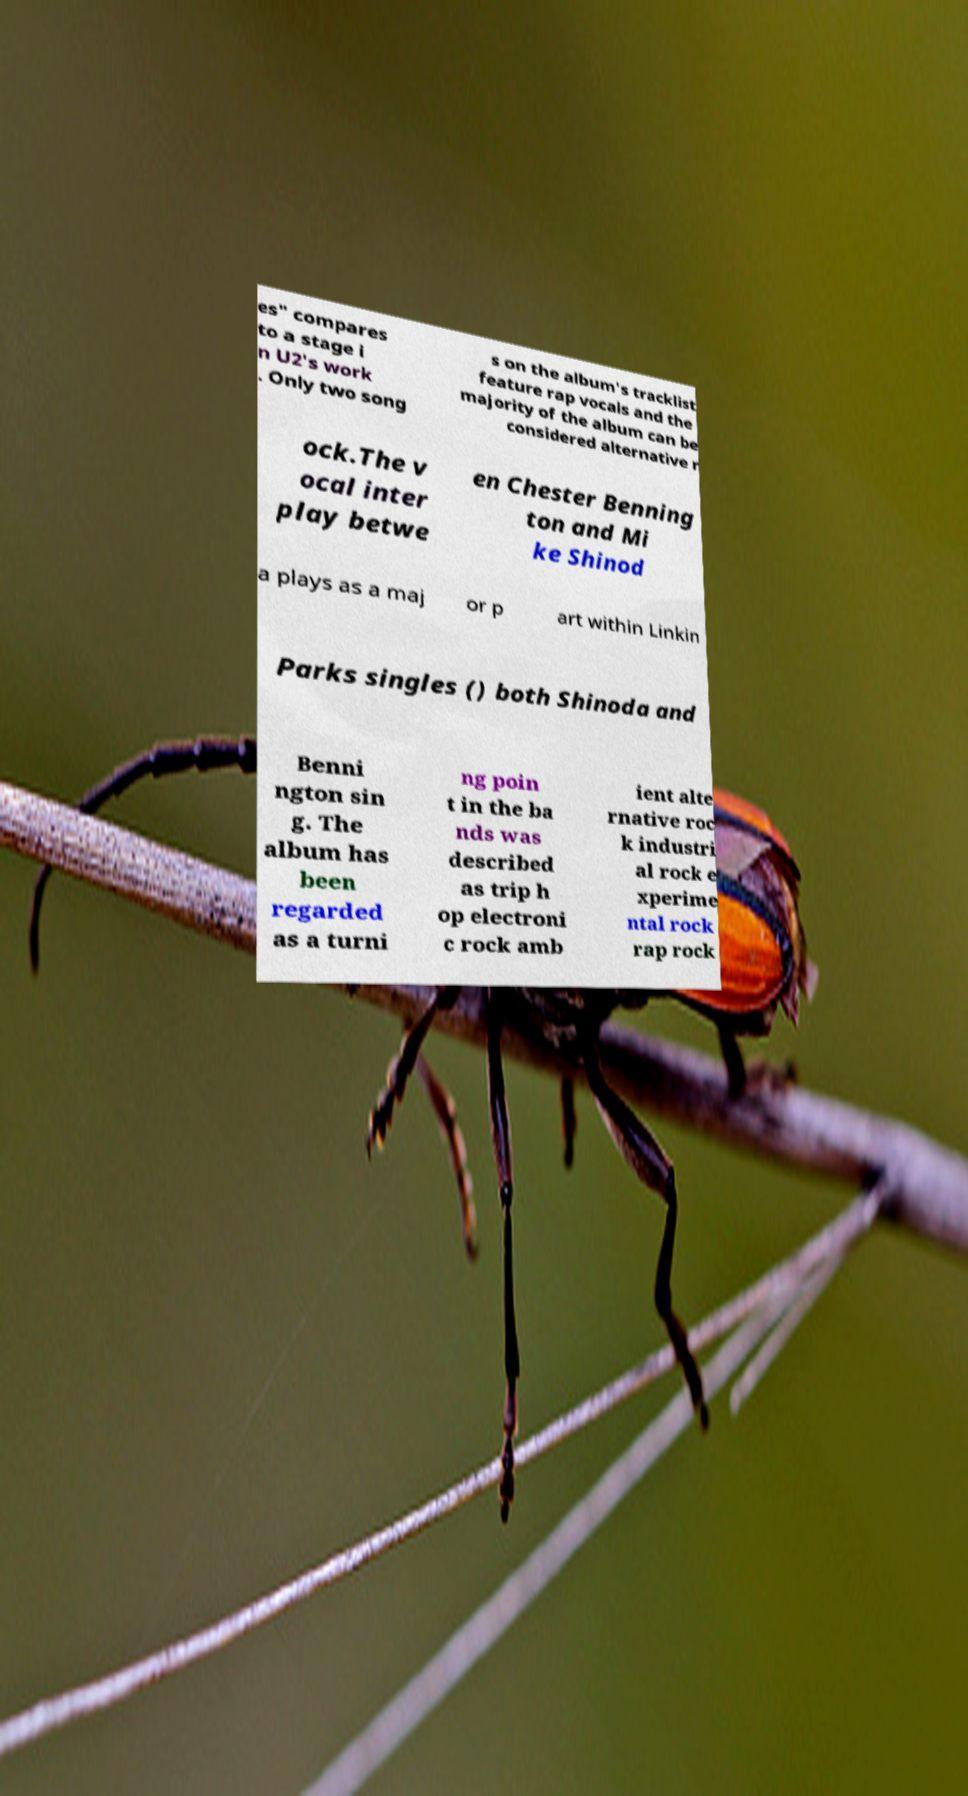I need the written content from this picture converted into text. Can you do that? es" compares to a stage i n U2's work . Only two song s on the album's tracklist feature rap vocals and the majority of the album can be considered alternative r ock.The v ocal inter play betwe en Chester Benning ton and Mi ke Shinod a plays as a maj or p art within Linkin Parks singles () both Shinoda and Benni ngton sin g. The album has been regarded as a turni ng poin t in the ba nds was described as trip h op electroni c rock amb ient alte rnative roc k industri al rock e xperime ntal rock rap rock 